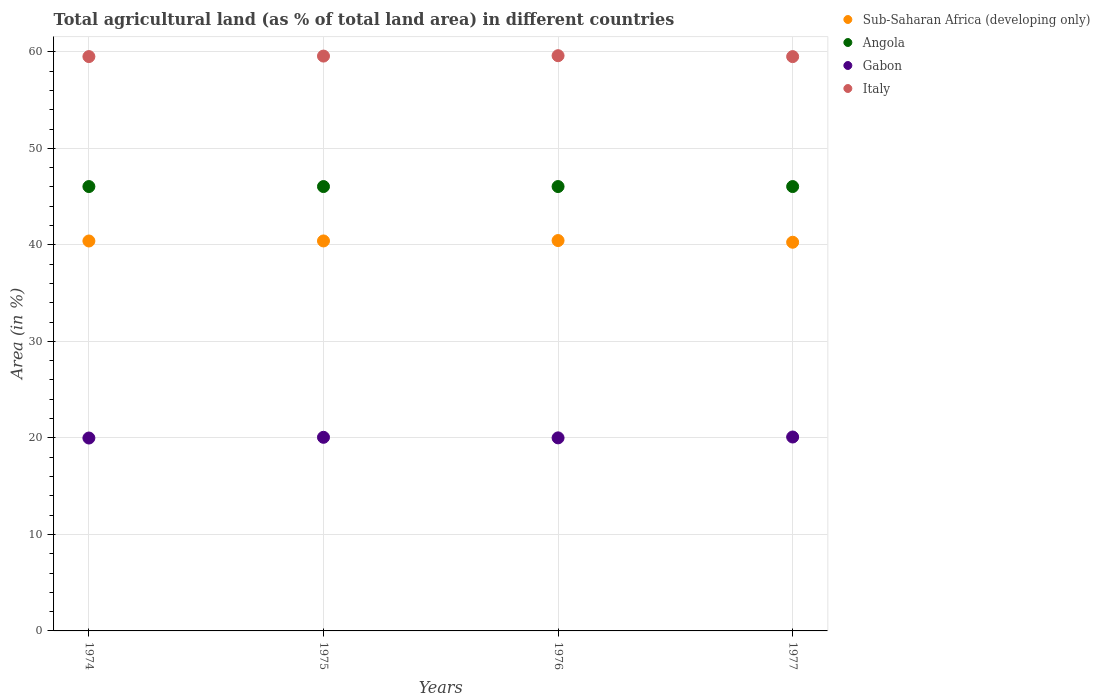What is the percentage of agricultural land in Gabon in 1974?
Provide a short and direct response. 19.99. Across all years, what is the maximum percentage of agricultural land in Sub-Saharan Africa (developing only)?
Provide a short and direct response. 40.45. Across all years, what is the minimum percentage of agricultural land in Sub-Saharan Africa (developing only)?
Offer a terse response. 40.27. In which year was the percentage of agricultural land in Angola maximum?
Provide a short and direct response. 1974. What is the total percentage of agricultural land in Sub-Saharan Africa (developing only) in the graph?
Offer a terse response. 161.52. What is the difference between the percentage of agricultural land in Italy in 1974 and the percentage of agricultural land in Gabon in 1977?
Offer a very short reply. 39.42. What is the average percentage of agricultural land in Angola per year?
Provide a short and direct response. 46.04. In the year 1975, what is the difference between the percentage of agricultural land in Sub-Saharan Africa (developing only) and percentage of agricultural land in Gabon?
Offer a very short reply. 20.35. What is the ratio of the percentage of agricultural land in Italy in 1974 to that in 1975?
Make the answer very short. 1. Is the percentage of agricultural land in Angola in 1974 less than that in 1975?
Give a very brief answer. No. Is the difference between the percentage of agricultural land in Sub-Saharan Africa (developing only) in 1975 and 1976 greater than the difference between the percentage of agricultural land in Gabon in 1975 and 1976?
Offer a terse response. No. What is the difference between the highest and the second highest percentage of agricultural land in Gabon?
Provide a succinct answer. 0.03. What is the difference between the highest and the lowest percentage of agricultural land in Sub-Saharan Africa (developing only)?
Your answer should be compact. 0.18. Is the sum of the percentage of agricultural land in Angola in 1974 and 1977 greater than the maximum percentage of agricultural land in Gabon across all years?
Your response must be concise. Yes. Is it the case that in every year, the sum of the percentage of agricultural land in Italy and percentage of agricultural land in Sub-Saharan Africa (developing only)  is greater than the sum of percentage of agricultural land in Angola and percentage of agricultural land in Gabon?
Ensure brevity in your answer.  Yes. Does the percentage of agricultural land in Gabon monotonically increase over the years?
Your response must be concise. No. Is the percentage of agricultural land in Sub-Saharan Africa (developing only) strictly greater than the percentage of agricultural land in Angola over the years?
Keep it short and to the point. No. Is the percentage of agricultural land in Gabon strictly less than the percentage of agricultural land in Italy over the years?
Provide a short and direct response. Yes. How many dotlines are there?
Your response must be concise. 4. Are the values on the major ticks of Y-axis written in scientific E-notation?
Your answer should be compact. No. Does the graph contain any zero values?
Offer a terse response. No. Does the graph contain grids?
Your answer should be very brief. Yes. What is the title of the graph?
Your answer should be very brief. Total agricultural land (as % of total land area) in different countries. What is the label or title of the X-axis?
Keep it short and to the point. Years. What is the label or title of the Y-axis?
Provide a succinct answer. Area (in %). What is the Area (in %) in Sub-Saharan Africa (developing only) in 1974?
Your answer should be compact. 40.4. What is the Area (in %) of Angola in 1974?
Offer a terse response. 46.04. What is the Area (in %) in Gabon in 1974?
Your answer should be compact. 19.99. What is the Area (in %) of Italy in 1974?
Offer a terse response. 59.51. What is the Area (in %) in Sub-Saharan Africa (developing only) in 1975?
Provide a short and direct response. 40.41. What is the Area (in %) of Angola in 1975?
Offer a terse response. 46.04. What is the Area (in %) in Gabon in 1975?
Give a very brief answer. 20.06. What is the Area (in %) of Italy in 1975?
Ensure brevity in your answer.  59.56. What is the Area (in %) of Sub-Saharan Africa (developing only) in 1976?
Provide a short and direct response. 40.45. What is the Area (in %) in Angola in 1976?
Ensure brevity in your answer.  46.04. What is the Area (in %) in Gabon in 1976?
Offer a terse response. 20. What is the Area (in %) of Italy in 1976?
Ensure brevity in your answer.  59.6. What is the Area (in %) of Sub-Saharan Africa (developing only) in 1977?
Provide a short and direct response. 40.27. What is the Area (in %) of Angola in 1977?
Give a very brief answer. 46.04. What is the Area (in %) of Gabon in 1977?
Ensure brevity in your answer.  20.09. What is the Area (in %) of Italy in 1977?
Give a very brief answer. 59.5. Across all years, what is the maximum Area (in %) in Sub-Saharan Africa (developing only)?
Provide a succinct answer. 40.45. Across all years, what is the maximum Area (in %) in Angola?
Make the answer very short. 46.04. Across all years, what is the maximum Area (in %) of Gabon?
Provide a short and direct response. 20.09. Across all years, what is the maximum Area (in %) of Italy?
Make the answer very short. 59.6. Across all years, what is the minimum Area (in %) of Sub-Saharan Africa (developing only)?
Provide a succinct answer. 40.27. Across all years, what is the minimum Area (in %) in Angola?
Offer a terse response. 46.04. Across all years, what is the minimum Area (in %) in Gabon?
Ensure brevity in your answer.  19.99. Across all years, what is the minimum Area (in %) in Italy?
Provide a short and direct response. 59.5. What is the total Area (in %) in Sub-Saharan Africa (developing only) in the graph?
Ensure brevity in your answer.  161.52. What is the total Area (in %) in Angola in the graph?
Offer a terse response. 184.17. What is the total Area (in %) in Gabon in the graph?
Your answer should be compact. 80.14. What is the total Area (in %) in Italy in the graph?
Make the answer very short. 238.17. What is the difference between the Area (in %) in Sub-Saharan Africa (developing only) in 1974 and that in 1975?
Your answer should be compact. -0. What is the difference between the Area (in %) of Gabon in 1974 and that in 1975?
Give a very brief answer. -0.07. What is the difference between the Area (in %) in Italy in 1974 and that in 1975?
Offer a terse response. -0.05. What is the difference between the Area (in %) in Sub-Saharan Africa (developing only) in 1974 and that in 1976?
Your answer should be very brief. -0.05. What is the difference between the Area (in %) of Gabon in 1974 and that in 1976?
Offer a very short reply. -0.02. What is the difference between the Area (in %) of Italy in 1974 and that in 1976?
Your answer should be compact. -0.09. What is the difference between the Area (in %) of Sub-Saharan Africa (developing only) in 1974 and that in 1977?
Ensure brevity in your answer.  0.13. What is the difference between the Area (in %) of Gabon in 1974 and that in 1977?
Provide a short and direct response. -0.1. What is the difference between the Area (in %) of Italy in 1974 and that in 1977?
Ensure brevity in your answer.  0. What is the difference between the Area (in %) of Sub-Saharan Africa (developing only) in 1975 and that in 1976?
Offer a terse response. -0.04. What is the difference between the Area (in %) in Gabon in 1975 and that in 1976?
Your answer should be compact. 0.06. What is the difference between the Area (in %) in Italy in 1975 and that in 1976?
Provide a succinct answer. -0.04. What is the difference between the Area (in %) of Sub-Saharan Africa (developing only) in 1975 and that in 1977?
Provide a succinct answer. 0.14. What is the difference between the Area (in %) in Gabon in 1975 and that in 1977?
Make the answer very short. -0.03. What is the difference between the Area (in %) in Italy in 1975 and that in 1977?
Your answer should be compact. 0.05. What is the difference between the Area (in %) of Sub-Saharan Africa (developing only) in 1976 and that in 1977?
Your answer should be very brief. 0.18. What is the difference between the Area (in %) of Gabon in 1976 and that in 1977?
Offer a terse response. -0.09. What is the difference between the Area (in %) of Italy in 1976 and that in 1977?
Your answer should be very brief. 0.1. What is the difference between the Area (in %) of Sub-Saharan Africa (developing only) in 1974 and the Area (in %) of Angola in 1975?
Your response must be concise. -5.64. What is the difference between the Area (in %) of Sub-Saharan Africa (developing only) in 1974 and the Area (in %) of Gabon in 1975?
Ensure brevity in your answer.  20.34. What is the difference between the Area (in %) of Sub-Saharan Africa (developing only) in 1974 and the Area (in %) of Italy in 1975?
Provide a short and direct response. -19.16. What is the difference between the Area (in %) in Angola in 1974 and the Area (in %) in Gabon in 1975?
Keep it short and to the point. 25.98. What is the difference between the Area (in %) in Angola in 1974 and the Area (in %) in Italy in 1975?
Provide a succinct answer. -13.52. What is the difference between the Area (in %) in Gabon in 1974 and the Area (in %) in Italy in 1975?
Keep it short and to the point. -39.57. What is the difference between the Area (in %) of Sub-Saharan Africa (developing only) in 1974 and the Area (in %) of Angola in 1976?
Provide a short and direct response. -5.64. What is the difference between the Area (in %) in Sub-Saharan Africa (developing only) in 1974 and the Area (in %) in Gabon in 1976?
Keep it short and to the point. 20.4. What is the difference between the Area (in %) in Sub-Saharan Africa (developing only) in 1974 and the Area (in %) in Italy in 1976?
Ensure brevity in your answer.  -19.2. What is the difference between the Area (in %) in Angola in 1974 and the Area (in %) in Gabon in 1976?
Keep it short and to the point. 26.04. What is the difference between the Area (in %) in Angola in 1974 and the Area (in %) in Italy in 1976?
Give a very brief answer. -13.56. What is the difference between the Area (in %) of Gabon in 1974 and the Area (in %) of Italy in 1976?
Ensure brevity in your answer.  -39.61. What is the difference between the Area (in %) of Sub-Saharan Africa (developing only) in 1974 and the Area (in %) of Angola in 1977?
Provide a succinct answer. -5.64. What is the difference between the Area (in %) of Sub-Saharan Africa (developing only) in 1974 and the Area (in %) of Gabon in 1977?
Keep it short and to the point. 20.31. What is the difference between the Area (in %) of Sub-Saharan Africa (developing only) in 1974 and the Area (in %) of Italy in 1977?
Your answer should be compact. -19.1. What is the difference between the Area (in %) of Angola in 1974 and the Area (in %) of Gabon in 1977?
Ensure brevity in your answer.  25.95. What is the difference between the Area (in %) in Angola in 1974 and the Area (in %) in Italy in 1977?
Your answer should be very brief. -13.46. What is the difference between the Area (in %) of Gabon in 1974 and the Area (in %) of Italy in 1977?
Make the answer very short. -39.52. What is the difference between the Area (in %) of Sub-Saharan Africa (developing only) in 1975 and the Area (in %) of Angola in 1976?
Your answer should be compact. -5.64. What is the difference between the Area (in %) in Sub-Saharan Africa (developing only) in 1975 and the Area (in %) in Gabon in 1976?
Your response must be concise. 20.4. What is the difference between the Area (in %) in Sub-Saharan Africa (developing only) in 1975 and the Area (in %) in Italy in 1976?
Provide a succinct answer. -19.19. What is the difference between the Area (in %) of Angola in 1975 and the Area (in %) of Gabon in 1976?
Your answer should be compact. 26.04. What is the difference between the Area (in %) of Angola in 1975 and the Area (in %) of Italy in 1976?
Ensure brevity in your answer.  -13.56. What is the difference between the Area (in %) in Gabon in 1975 and the Area (in %) in Italy in 1976?
Make the answer very short. -39.54. What is the difference between the Area (in %) in Sub-Saharan Africa (developing only) in 1975 and the Area (in %) in Angola in 1977?
Make the answer very short. -5.64. What is the difference between the Area (in %) of Sub-Saharan Africa (developing only) in 1975 and the Area (in %) of Gabon in 1977?
Offer a very short reply. 20.31. What is the difference between the Area (in %) in Sub-Saharan Africa (developing only) in 1975 and the Area (in %) in Italy in 1977?
Give a very brief answer. -19.1. What is the difference between the Area (in %) in Angola in 1975 and the Area (in %) in Gabon in 1977?
Ensure brevity in your answer.  25.95. What is the difference between the Area (in %) of Angola in 1975 and the Area (in %) of Italy in 1977?
Offer a very short reply. -13.46. What is the difference between the Area (in %) of Gabon in 1975 and the Area (in %) of Italy in 1977?
Provide a short and direct response. -39.44. What is the difference between the Area (in %) of Sub-Saharan Africa (developing only) in 1976 and the Area (in %) of Angola in 1977?
Your answer should be compact. -5.6. What is the difference between the Area (in %) of Sub-Saharan Africa (developing only) in 1976 and the Area (in %) of Gabon in 1977?
Make the answer very short. 20.35. What is the difference between the Area (in %) of Sub-Saharan Africa (developing only) in 1976 and the Area (in %) of Italy in 1977?
Provide a short and direct response. -19.06. What is the difference between the Area (in %) in Angola in 1976 and the Area (in %) in Gabon in 1977?
Your answer should be very brief. 25.95. What is the difference between the Area (in %) of Angola in 1976 and the Area (in %) of Italy in 1977?
Your answer should be very brief. -13.46. What is the difference between the Area (in %) in Gabon in 1976 and the Area (in %) in Italy in 1977?
Offer a terse response. -39.5. What is the average Area (in %) of Sub-Saharan Africa (developing only) per year?
Provide a short and direct response. 40.38. What is the average Area (in %) of Angola per year?
Offer a very short reply. 46.04. What is the average Area (in %) of Gabon per year?
Your answer should be compact. 20.04. What is the average Area (in %) in Italy per year?
Give a very brief answer. 59.54. In the year 1974, what is the difference between the Area (in %) in Sub-Saharan Africa (developing only) and Area (in %) in Angola?
Ensure brevity in your answer.  -5.64. In the year 1974, what is the difference between the Area (in %) in Sub-Saharan Africa (developing only) and Area (in %) in Gabon?
Give a very brief answer. 20.41. In the year 1974, what is the difference between the Area (in %) of Sub-Saharan Africa (developing only) and Area (in %) of Italy?
Keep it short and to the point. -19.11. In the year 1974, what is the difference between the Area (in %) of Angola and Area (in %) of Gabon?
Keep it short and to the point. 26.05. In the year 1974, what is the difference between the Area (in %) of Angola and Area (in %) of Italy?
Make the answer very short. -13.47. In the year 1974, what is the difference between the Area (in %) in Gabon and Area (in %) in Italy?
Your response must be concise. -39.52. In the year 1975, what is the difference between the Area (in %) of Sub-Saharan Africa (developing only) and Area (in %) of Angola?
Ensure brevity in your answer.  -5.64. In the year 1975, what is the difference between the Area (in %) of Sub-Saharan Africa (developing only) and Area (in %) of Gabon?
Ensure brevity in your answer.  20.35. In the year 1975, what is the difference between the Area (in %) of Sub-Saharan Africa (developing only) and Area (in %) of Italy?
Keep it short and to the point. -19.15. In the year 1975, what is the difference between the Area (in %) of Angola and Area (in %) of Gabon?
Keep it short and to the point. 25.98. In the year 1975, what is the difference between the Area (in %) of Angola and Area (in %) of Italy?
Your response must be concise. -13.52. In the year 1975, what is the difference between the Area (in %) of Gabon and Area (in %) of Italy?
Ensure brevity in your answer.  -39.5. In the year 1976, what is the difference between the Area (in %) in Sub-Saharan Africa (developing only) and Area (in %) in Angola?
Offer a terse response. -5.6. In the year 1976, what is the difference between the Area (in %) in Sub-Saharan Africa (developing only) and Area (in %) in Gabon?
Offer a very short reply. 20.44. In the year 1976, what is the difference between the Area (in %) in Sub-Saharan Africa (developing only) and Area (in %) in Italy?
Offer a very short reply. -19.15. In the year 1976, what is the difference between the Area (in %) in Angola and Area (in %) in Gabon?
Provide a short and direct response. 26.04. In the year 1976, what is the difference between the Area (in %) in Angola and Area (in %) in Italy?
Give a very brief answer. -13.56. In the year 1976, what is the difference between the Area (in %) in Gabon and Area (in %) in Italy?
Your answer should be compact. -39.6. In the year 1977, what is the difference between the Area (in %) of Sub-Saharan Africa (developing only) and Area (in %) of Angola?
Your answer should be compact. -5.77. In the year 1977, what is the difference between the Area (in %) in Sub-Saharan Africa (developing only) and Area (in %) in Gabon?
Keep it short and to the point. 20.18. In the year 1977, what is the difference between the Area (in %) of Sub-Saharan Africa (developing only) and Area (in %) of Italy?
Give a very brief answer. -19.23. In the year 1977, what is the difference between the Area (in %) in Angola and Area (in %) in Gabon?
Offer a terse response. 25.95. In the year 1977, what is the difference between the Area (in %) in Angola and Area (in %) in Italy?
Offer a terse response. -13.46. In the year 1977, what is the difference between the Area (in %) of Gabon and Area (in %) of Italy?
Ensure brevity in your answer.  -39.41. What is the ratio of the Area (in %) of Sub-Saharan Africa (developing only) in 1974 to that in 1975?
Your answer should be compact. 1. What is the ratio of the Area (in %) in Italy in 1974 to that in 1975?
Offer a terse response. 1. What is the ratio of the Area (in %) in Sub-Saharan Africa (developing only) in 1974 to that in 1976?
Your response must be concise. 1. What is the ratio of the Area (in %) of Angola in 1974 to that in 1976?
Offer a very short reply. 1. What is the ratio of the Area (in %) in Gabon in 1974 to that in 1976?
Keep it short and to the point. 1. What is the ratio of the Area (in %) of Italy in 1974 to that in 1976?
Keep it short and to the point. 1. What is the ratio of the Area (in %) of Sub-Saharan Africa (developing only) in 1974 to that in 1977?
Your answer should be very brief. 1. What is the ratio of the Area (in %) in Angola in 1974 to that in 1977?
Provide a short and direct response. 1. What is the ratio of the Area (in %) in Sub-Saharan Africa (developing only) in 1975 to that in 1976?
Offer a terse response. 1. What is the ratio of the Area (in %) of Italy in 1975 to that in 1976?
Ensure brevity in your answer.  1. What is the ratio of the Area (in %) in Sub-Saharan Africa (developing only) in 1975 to that in 1977?
Keep it short and to the point. 1. What is the ratio of the Area (in %) in Angola in 1975 to that in 1977?
Give a very brief answer. 1. What is the ratio of the Area (in %) of Italy in 1975 to that in 1977?
Offer a terse response. 1. What is the ratio of the Area (in %) in Sub-Saharan Africa (developing only) in 1976 to that in 1977?
Make the answer very short. 1. What is the ratio of the Area (in %) of Italy in 1976 to that in 1977?
Your answer should be very brief. 1. What is the difference between the highest and the second highest Area (in %) in Sub-Saharan Africa (developing only)?
Keep it short and to the point. 0.04. What is the difference between the highest and the second highest Area (in %) of Gabon?
Give a very brief answer. 0.03. What is the difference between the highest and the second highest Area (in %) in Italy?
Provide a succinct answer. 0.04. What is the difference between the highest and the lowest Area (in %) in Sub-Saharan Africa (developing only)?
Ensure brevity in your answer.  0.18. What is the difference between the highest and the lowest Area (in %) in Gabon?
Ensure brevity in your answer.  0.1. What is the difference between the highest and the lowest Area (in %) in Italy?
Offer a very short reply. 0.1. 